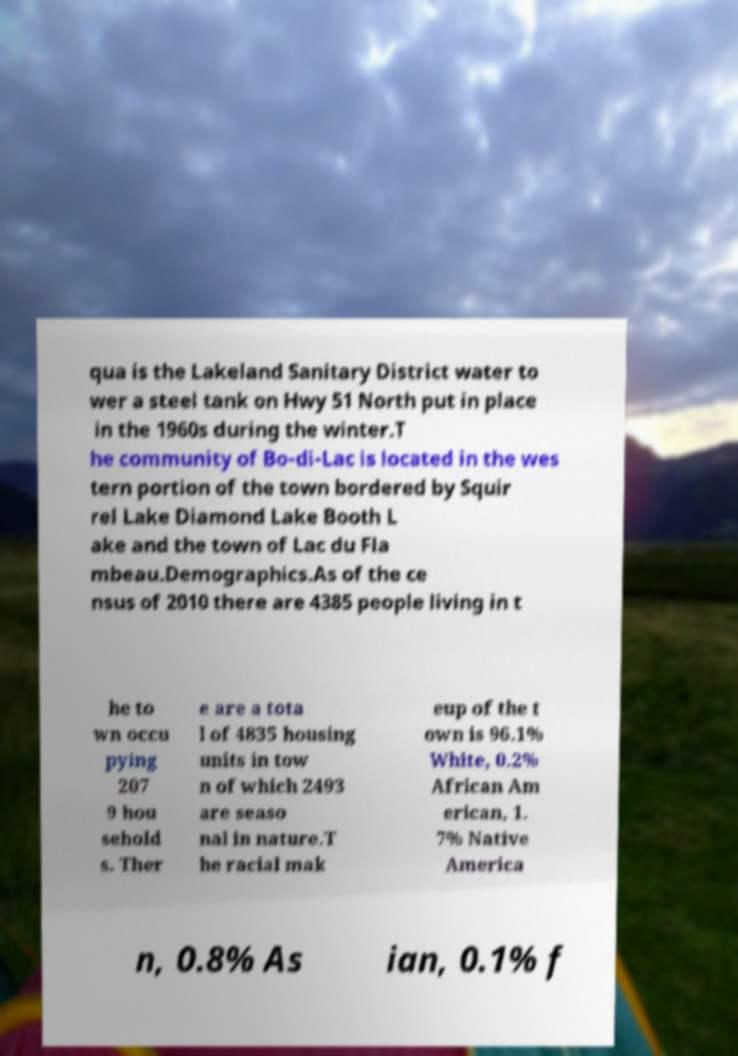Could you extract and type out the text from this image? qua is the Lakeland Sanitary District water to wer a steel tank on Hwy 51 North put in place in the 1960s during the winter.T he community of Bo-di-Lac is located in the wes tern portion of the town bordered by Squir rel Lake Diamond Lake Booth L ake and the town of Lac du Fla mbeau.Demographics.As of the ce nsus of 2010 there are 4385 people living in t he to wn occu pying 207 9 hou sehold s. Ther e are a tota l of 4835 housing units in tow n of which 2493 are seaso nal in nature.T he racial mak eup of the t own is 96.1% White, 0.2% African Am erican, 1. 7% Native America n, 0.8% As ian, 0.1% f 